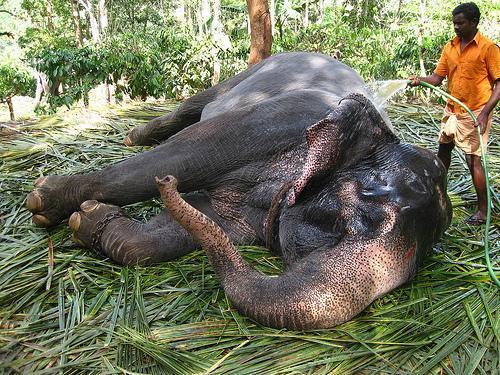How many elephants are there?
Give a very brief answer. 1. 